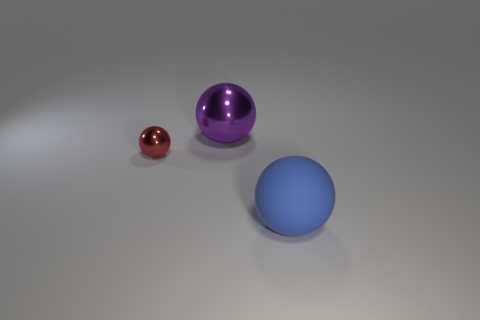Subtract all big purple metal spheres. How many spheres are left? 2 Add 3 small green rubber cubes. How many objects exist? 6 Subtract all purple spheres. How many spheres are left? 2 Subtract 1 balls. How many balls are left? 2 Add 2 big purple balls. How many big purple balls exist? 3 Subtract 0 yellow balls. How many objects are left? 3 Subtract all blue balls. Subtract all blue cylinders. How many balls are left? 2 Subtract all green cylinders. How many blue spheres are left? 1 Subtract all small spheres. Subtract all red balls. How many objects are left? 1 Add 2 spheres. How many spheres are left? 5 